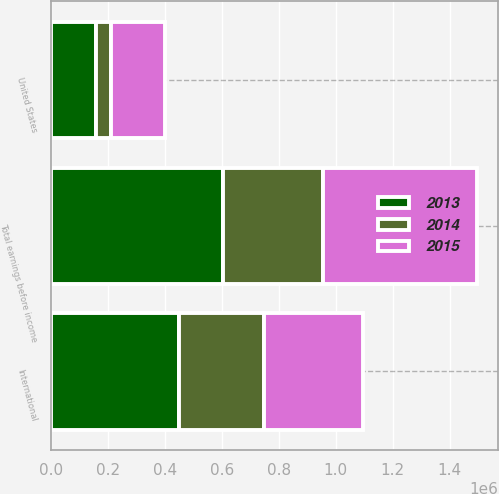Convert chart. <chart><loc_0><loc_0><loc_500><loc_500><stacked_bar_chart><ecel><fcel>United States<fcel>International<fcel>Total earnings before income<nl><fcel>2013<fcel>155120<fcel>448795<fcel>603915<nl><fcel>2015<fcel>190769<fcel>349219<fcel>539988<nl><fcel>2014<fcel>54424<fcel>297398<fcel>351822<nl></chart> 